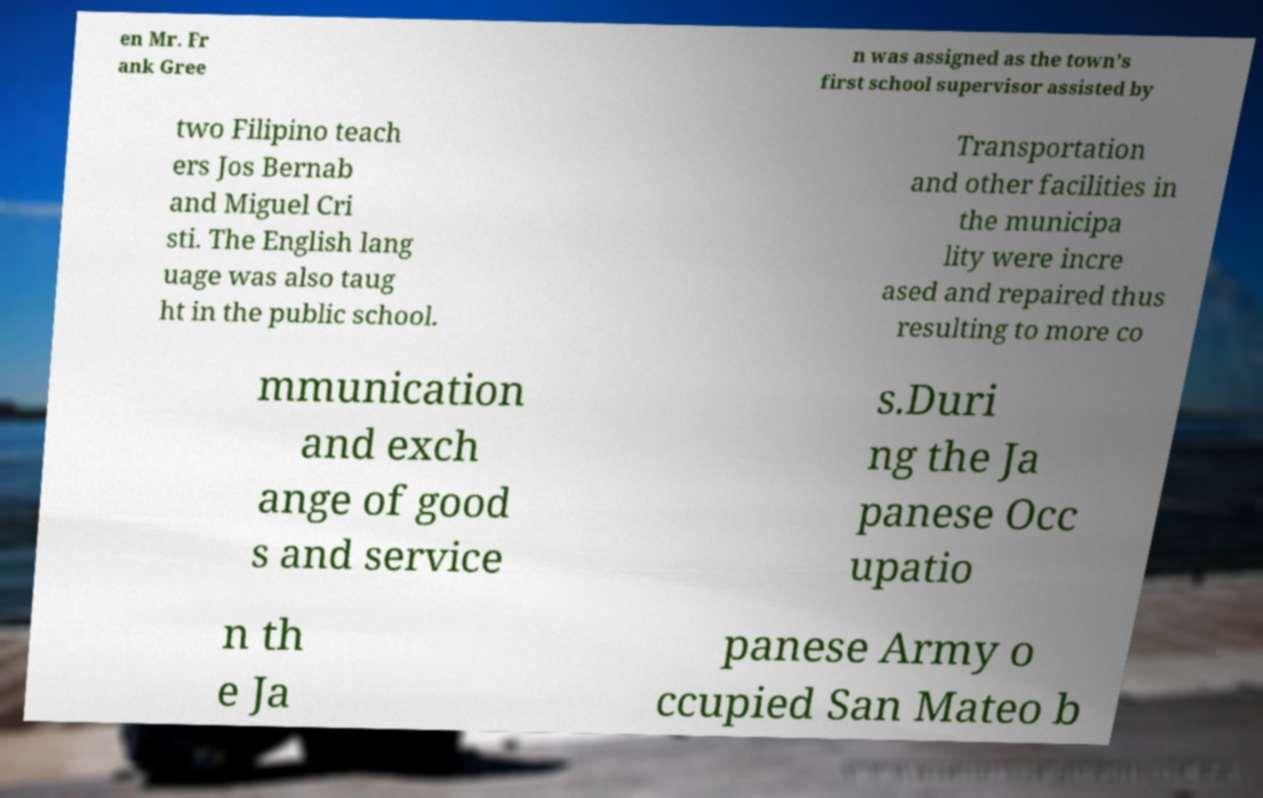What messages or text are displayed in this image? I need them in a readable, typed format. en Mr. Fr ank Gree n was assigned as the town’s first school supervisor assisted by two Filipino teach ers Jos Bernab and Miguel Cri sti. The English lang uage was also taug ht in the public school. Transportation and other facilities in the municipa lity were incre ased and repaired thus resulting to more co mmunication and exch ange of good s and service s.Duri ng the Ja panese Occ upatio n th e Ja panese Army o ccupied San Mateo b 